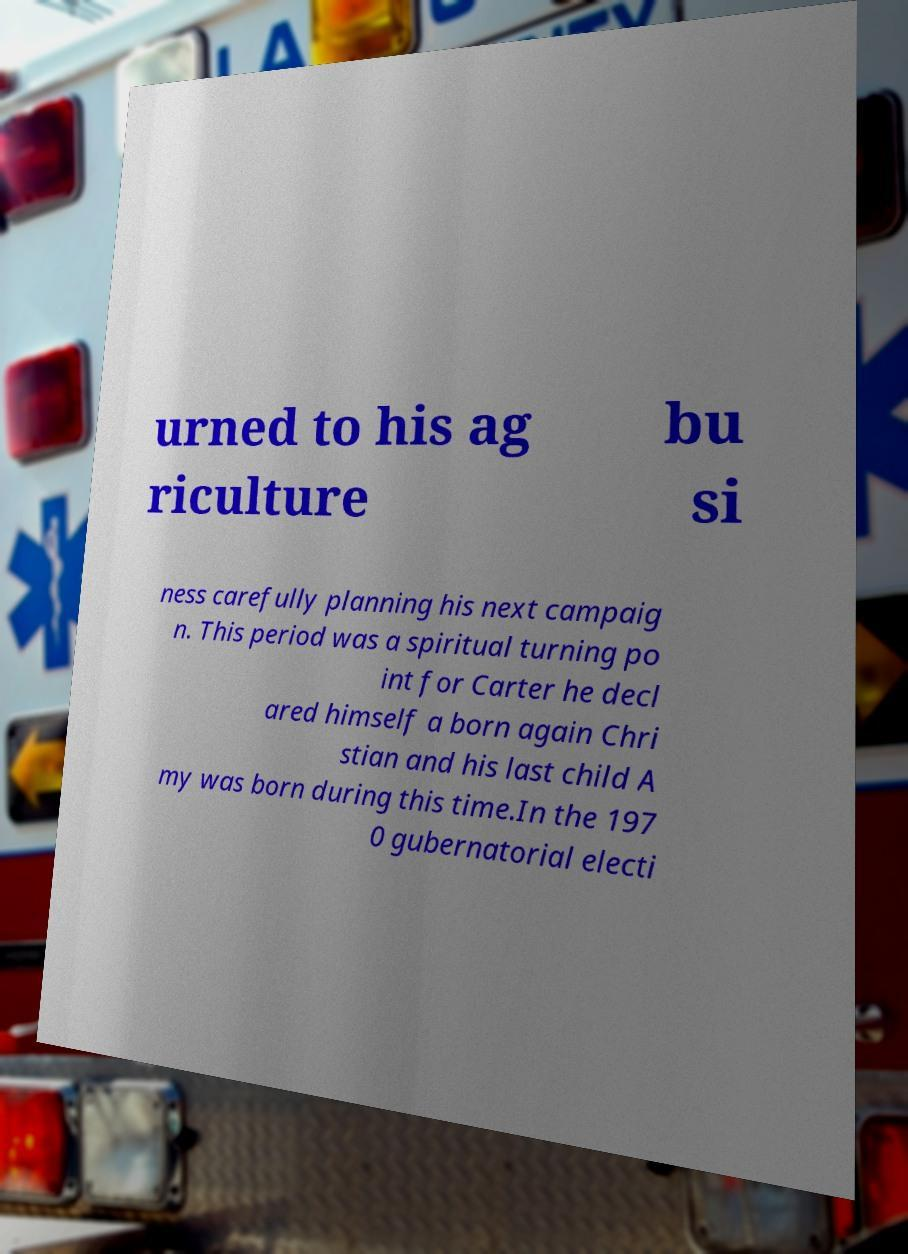There's text embedded in this image that I need extracted. Can you transcribe it verbatim? urned to his ag riculture bu si ness carefully planning his next campaig n. This period was a spiritual turning po int for Carter he decl ared himself a born again Chri stian and his last child A my was born during this time.In the 197 0 gubernatorial electi 